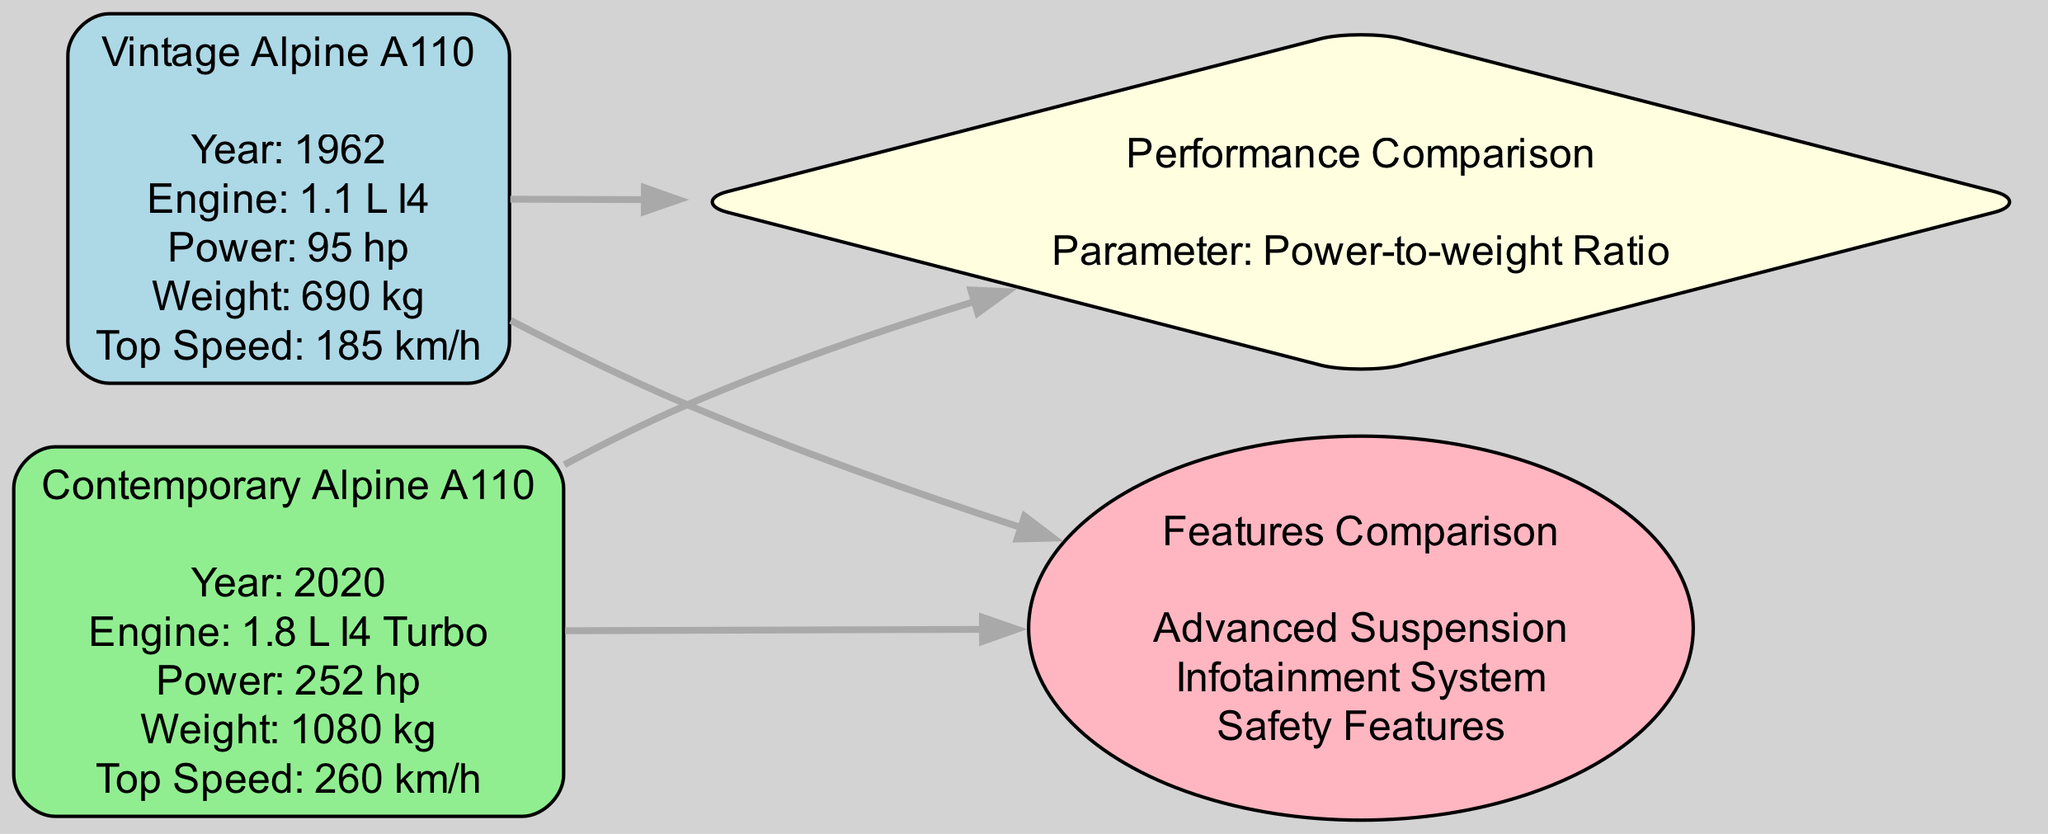What is the year of the Vintage Alpine A110? The year attribute of the Vintage Alpine A110 node specifies the production year, which is shown directly in the node itself.
Answer: 1962 What is the weight of the Contemporary Alpine A110? The weight attribute of the Contemporary Alpine A110 node is indicated clearly within the node's details, allowing us to find the answer directly.
Answer: 1080 kg What feature is listed under Features Comparison? The Features Comparison node contains a list where each feature is presented. By inspecting that node, one can identify features mentioned such as "Advanced Suspension".
Answer: Advanced Suspension Which car has a higher power output? To determine which car possesses a higher power, we compare the power attributes of both car nodes. The Vintage Alpine A110 has 95 hp, whereas the Contemporary Alpine A110 has 252 hp. Since 252 hp is greater than 95 hp, the Contemporary model is the answer.
Answer: Contemporary Alpine A110 What is the top speed of the Vintage Alpine A110? Top speed information can be found directly within the Vintage Alpine A110 node. By referring to this node, the top speed can be noted without needing to infer from other parts of the diagram.
Answer: 185 km/h Which node is connected to both Vintage Alpine A110 and Contemporary Alpine A110? The diagram illustrates the relationship between nodes through edges. By tracing the edges, we can see that both car nodes connect to the Performance Comparison node, indicating the common comparison theme between the two.
Answer: Performance Comparison What is the parameter evaluated in the Performance Comparison node? The Performance Comparison node contains an attribute called "parameter," which can be seen directly in the label. This straightforward identification confirms what is being assessed in that comparison.
Answer: Power-to-weight Ratio How many features are listed in the Features Comparison node? By counting each individual feature mentioned within the Features Comparison node’s attribute, one can arrive at the total count. There are three features listed, each separated by commas in the description.
Answer: 3 